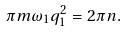Convert formula to latex. <formula><loc_0><loc_0><loc_500><loc_500>\pi m \omega _ { 1 } q _ { 1 } ^ { 2 } = 2 \pi n .</formula> 